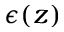Convert formula to latex. <formula><loc_0><loc_0><loc_500><loc_500>\epsilon ( z )</formula> 